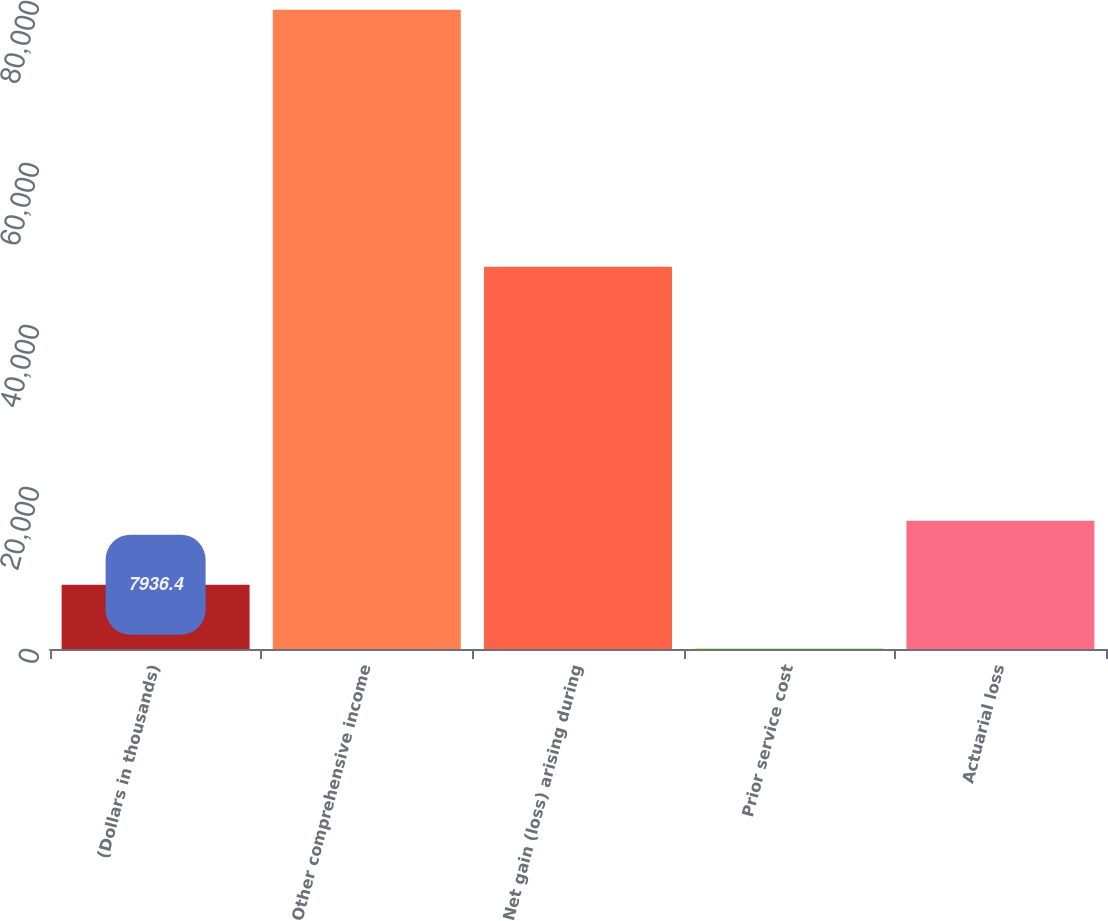Convert chart. <chart><loc_0><loc_0><loc_500><loc_500><bar_chart><fcel>(Dollars in thousands)<fcel>Other comprehensive income<fcel>Net gain (loss) arising during<fcel>Prior service cost<fcel>Actuarial loss<nl><fcel>7936.4<fcel>78923<fcel>47177<fcel>49<fcel>15823.8<nl></chart> 